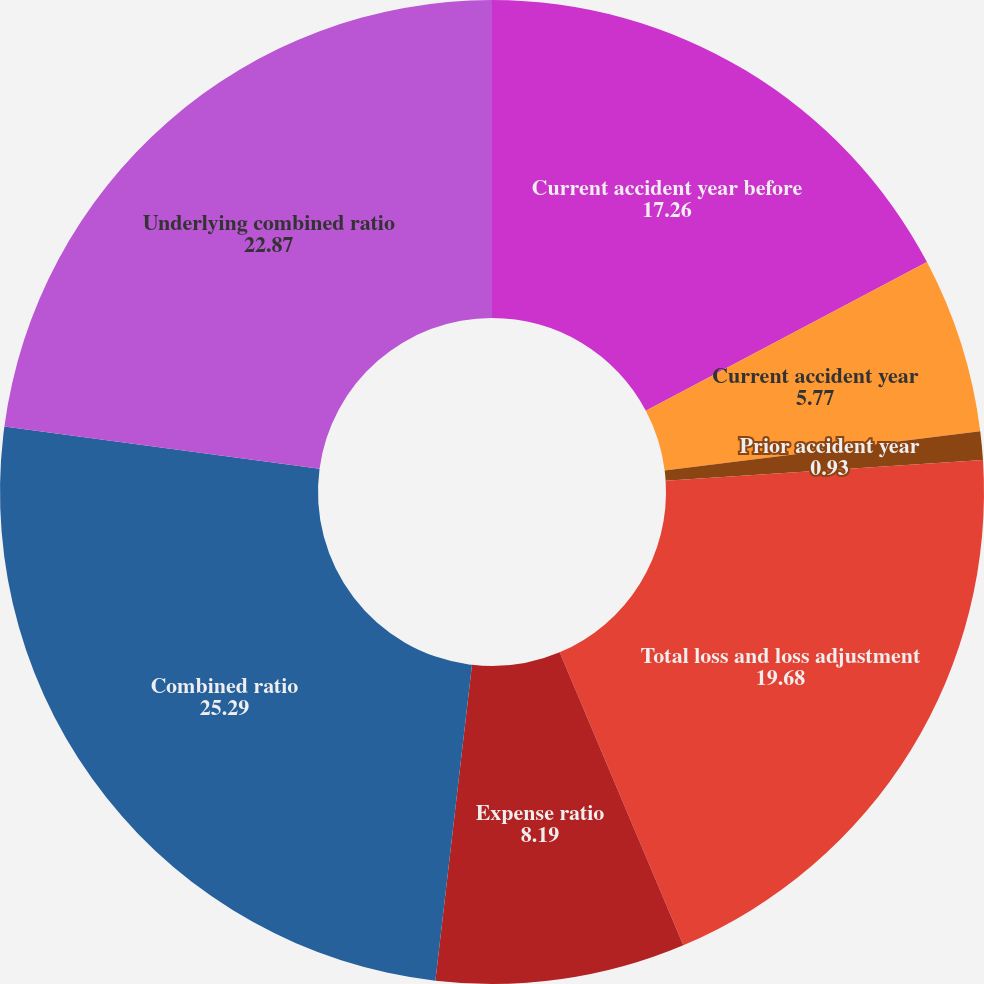<chart> <loc_0><loc_0><loc_500><loc_500><pie_chart><fcel>Current accident year before<fcel>Current accident year<fcel>Prior accident year<fcel>Total loss and loss adjustment<fcel>Expense ratio<fcel>Combined ratio<fcel>Underlying combined ratio<nl><fcel>17.26%<fcel>5.77%<fcel>0.93%<fcel>19.68%<fcel>8.19%<fcel>25.29%<fcel>22.87%<nl></chart> 